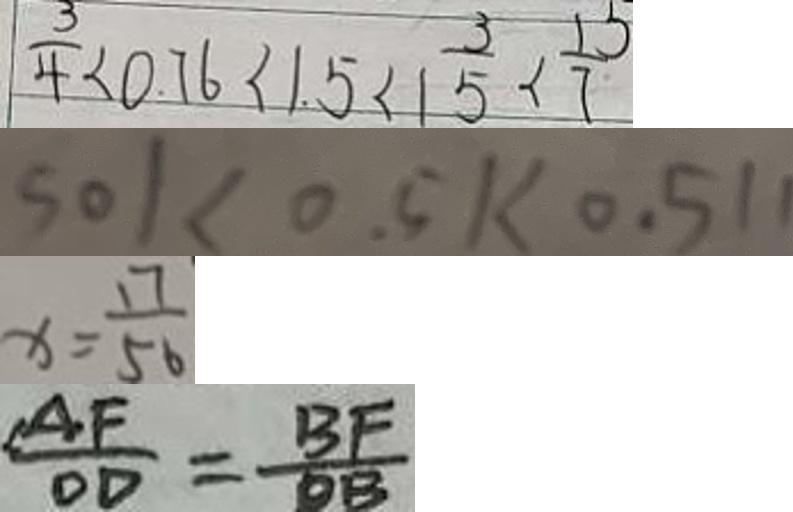<formula> <loc_0><loc_0><loc_500><loc_500>\frac { 3 } { 4 } < 0 . 7 6 < 1 . 5 < 1 \frac { 3 } { 5 } < \frac { 1 5 } { 7 } 
 5 0 1 < 0 . 5 1 < 0 . 5 1 1 
 x = \frac { 1 7 } { 5 6 } 
 \frac { A F } { O D } = \frac { B F } { O B }</formula> 